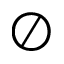Convert formula to latex. <formula><loc_0><loc_0><loc_500><loc_500>\oslash</formula> 